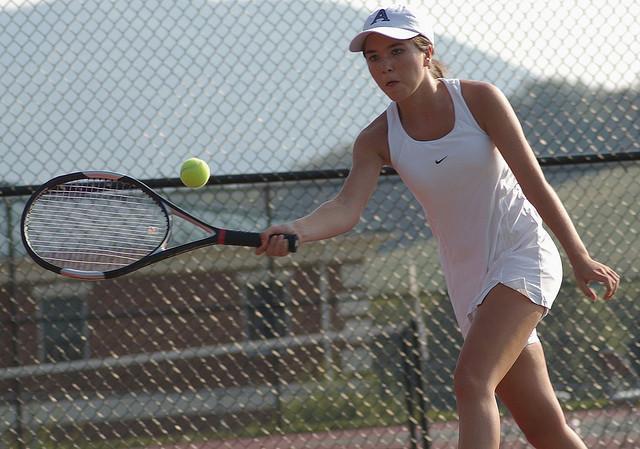How many tennis balls do you see?
Give a very brief answer. 1. 